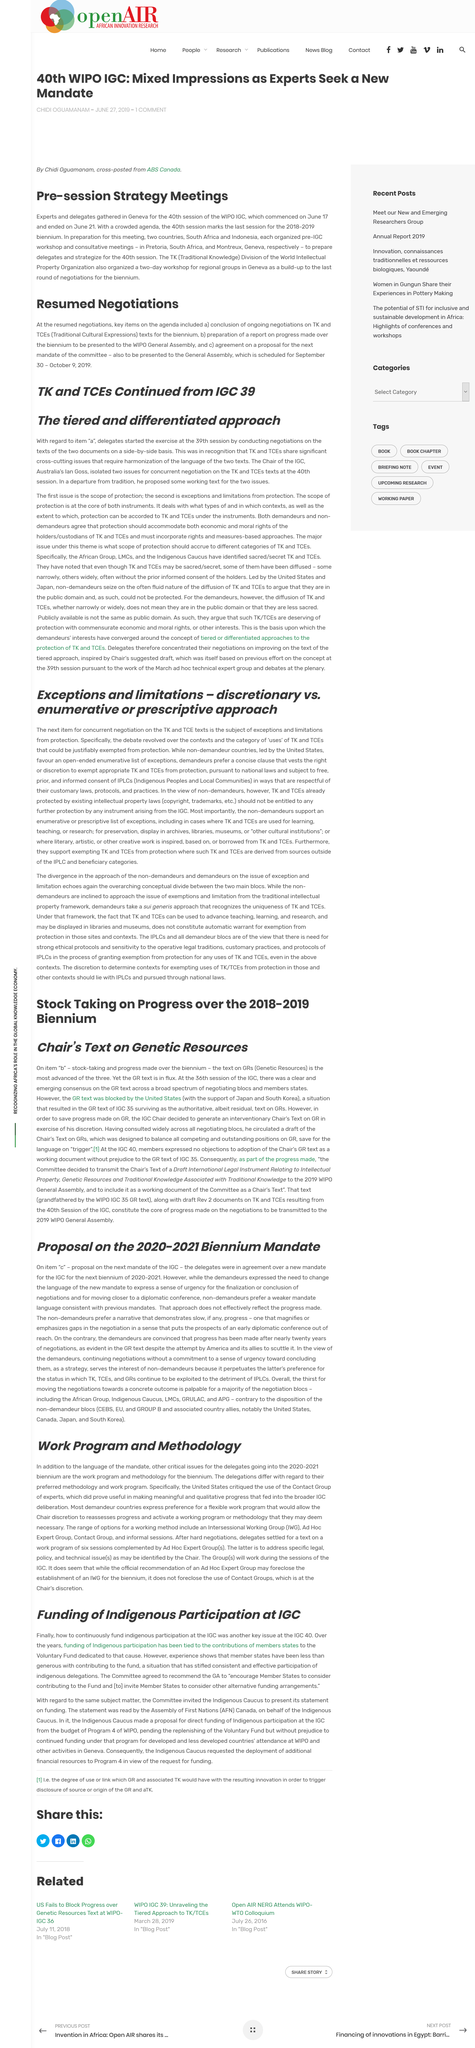Specify some key components in this picture. The 40th session of the World Intellectual Property Organization (WIPO) Intergovernmental Committee (IGC) ended on June 21. South Africa and Indonesia, in preparation for this meeting, held pre-IGC workshops and consultative meetings to ensure their readiness and to coordinate their efforts with other members of the IGC. The funding for this initiative is tied to the contributions of the member states, which have made significant strides in investing in renewable energy and reducing their carbon footprint. The funding has been insufficient and the contribution has been minimal, resulting in a problem for the funding. The 40th session of the World Intellectual Property Organization (WIPO) Intergovernmental Committee (IGC) began on June 17. 